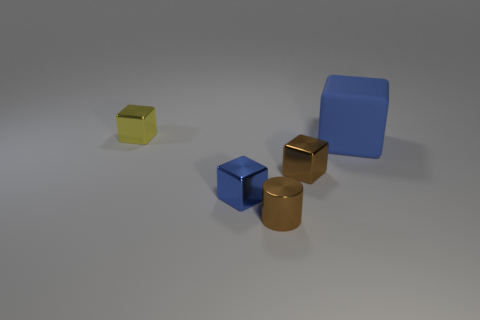Is there anything else that is the same size as the blue rubber block?
Keep it short and to the point. No. Is the material of the large blue object the same as the tiny yellow block?
Keep it short and to the point. No. Is the number of small shiny blocks greater than the number of things?
Provide a short and direct response. No. There is a yellow metal block; is its size the same as the blue object to the right of the tiny brown cylinder?
Provide a succinct answer. No. What color is the tiny thing that is to the left of the tiny blue metal thing?
Ensure brevity in your answer.  Yellow. How many blue objects are either large rubber objects or big spheres?
Make the answer very short. 1. The shiny cylinder has what color?
Give a very brief answer. Brown. Is there any other thing that is the same material as the big thing?
Keep it short and to the point. No. Is the number of big rubber blocks that are behind the tiny yellow object less than the number of yellow metallic objects that are to the right of the metal cylinder?
Your answer should be compact. No. There is a metal thing that is behind the tiny blue metal block and in front of the large blue matte block; what is its shape?
Offer a very short reply. Cube. 